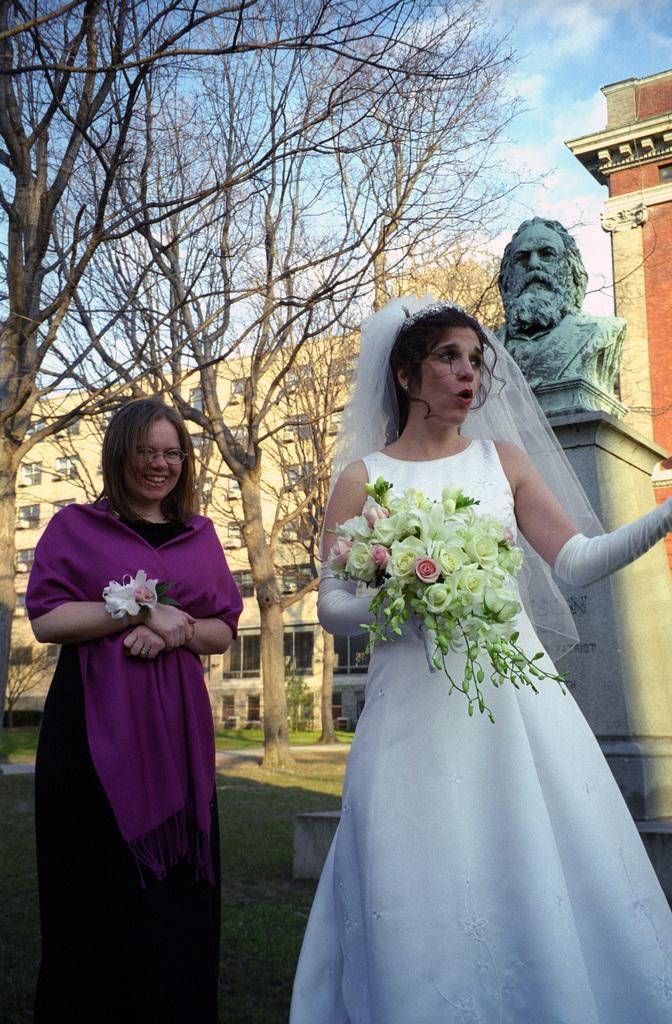Describe this image in one or two sentences. In this image we can see there are two persons standing and holding flowers. In the background, we can see a statue with pillar and there are trees, grass, buildings and sky. 